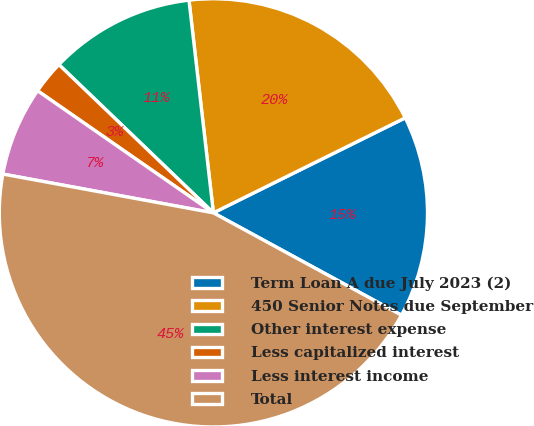Convert chart to OTSL. <chart><loc_0><loc_0><loc_500><loc_500><pie_chart><fcel>Term Loan A due July 2023 (2)<fcel>450 Senior Notes due September<fcel>Other interest expense<fcel>Less capitalized interest<fcel>Less interest income<fcel>Total<nl><fcel>15.25%<fcel>19.5%<fcel>11.01%<fcel>2.51%<fcel>6.76%<fcel>44.97%<nl></chart> 